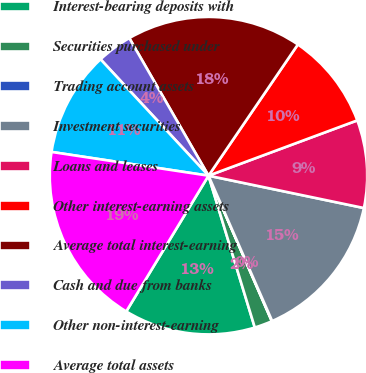Convert chart to OTSL. <chart><loc_0><loc_0><loc_500><loc_500><pie_chart><fcel>Interest-bearing deposits with<fcel>Securities purchased under<fcel>Trading account assets<fcel>Investment securities<fcel>Loans and leases<fcel>Other interest-earning assets<fcel>Average total interest-earning<fcel>Cash and due from banks<fcel>Other non-interest-earning<fcel>Average total assets<nl><fcel>13.38%<fcel>1.82%<fcel>0.04%<fcel>15.16%<fcel>8.93%<fcel>9.82%<fcel>17.83%<fcel>3.59%<fcel>10.71%<fcel>18.72%<nl></chart> 